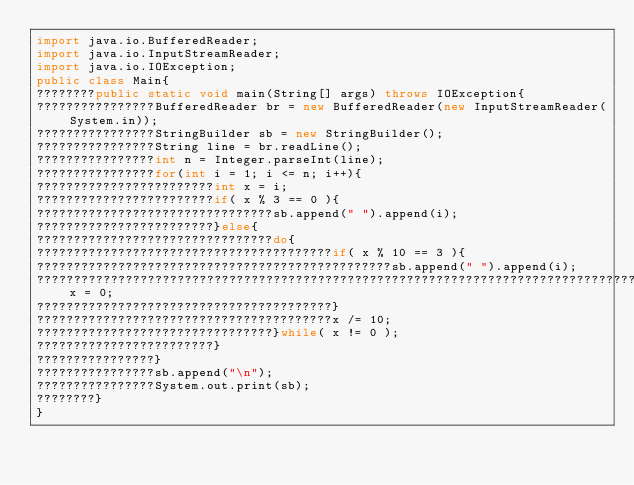Convert code to text. <code><loc_0><loc_0><loc_500><loc_500><_Java_>import java.io.BufferedReader;
import java.io.InputStreamReader;
import java.io.IOException;
public class Main{
????????public static void main(String[] args) throws IOException{
????????????????BufferedReader br = new BufferedReader(new InputStreamReader(System.in));
????????????????StringBuilder sb = new StringBuilder();
????????????????String line = br.readLine();
????????????????int n = Integer.parseInt(line);
????????????????for(int i = 1; i <= n; i++){
????????????????????????int x = i;
????????????????????????if( x % 3 == 0 ){
????????????????????????????????sb.append(" ").append(i);
????????????????????????}else{
????????????????????????????????do{
????????????????????????????????????????if( x % 10 == 3 ){
????????????????????????????????????????????????sb.append(" ").append(i);
????????????????????????????????????????????????????????????????????????????????????????????????x = 0;
????????????????????????????????????????}
????????????????????????????????????????x /= 10;
????????????????????????????????}while( x != 0 );
????????????????????????}
????????????????}
????????????????sb.append("\n");
????????????????System.out.print(sb);
????????}
}</code> 